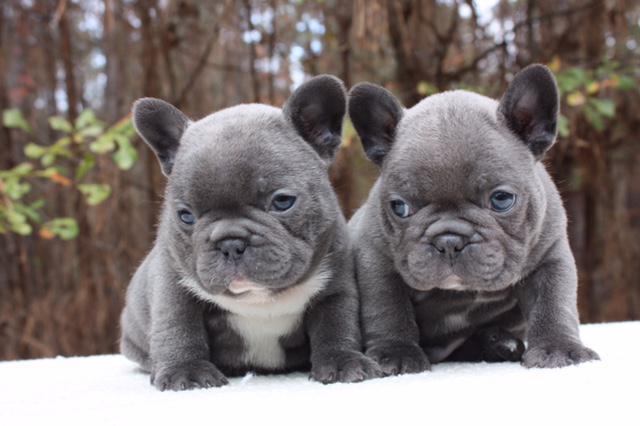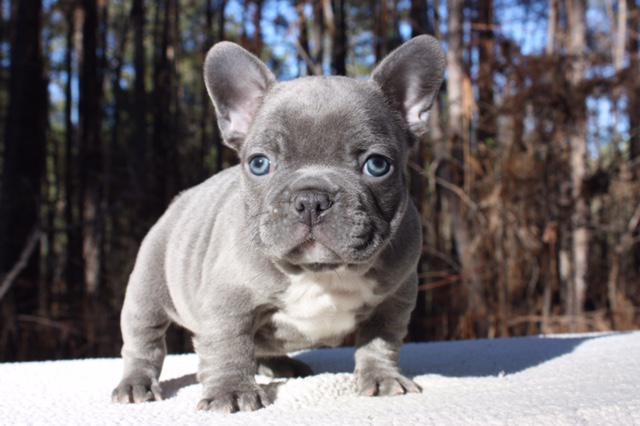The first image is the image on the left, the second image is the image on the right. Examine the images to the left and right. Is the description "The dog in the image on the right is outside." accurate? Answer yes or no. Yes. The first image is the image on the left, the second image is the image on the right. Analyze the images presented: Is the assertion "All of the dogs are charcoal gray, with at most a patch of white on the chest, and all dogs have blue eyes." valid? Answer yes or no. Yes. 